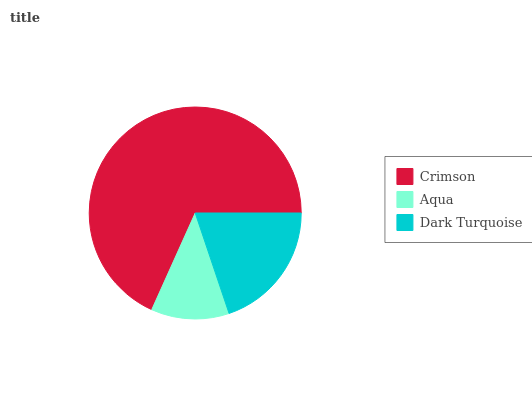Is Aqua the minimum?
Answer yes or no. Yes. Is Crimson the maximum?
Answer yes or no. Yes. Is Dark Turquoise the minimum?
Answer yes or no. No. Is Dark Turquoise the maximum?
Answer yes or no. No. Is Dark Turquoise greater than Aqua?
Answer yes or no. Yes. Is Aqua less than Dark Turquoise?
Answer yes or no. Yes. Is Aqua greater than Dark Turquoise?
Answer yes or no. No. Is Dark Turquoise less than Aqua?
Answer yes or no. No. Is Dark Turquoise the high median?
Answer yes or no. Yes. Is Dark Turquoise the low median?
Answer yes or no. Yes. Is Crimson the high median?
Answer yes or no. No. Is Aqua the low median?
Answer yes or no. No. 